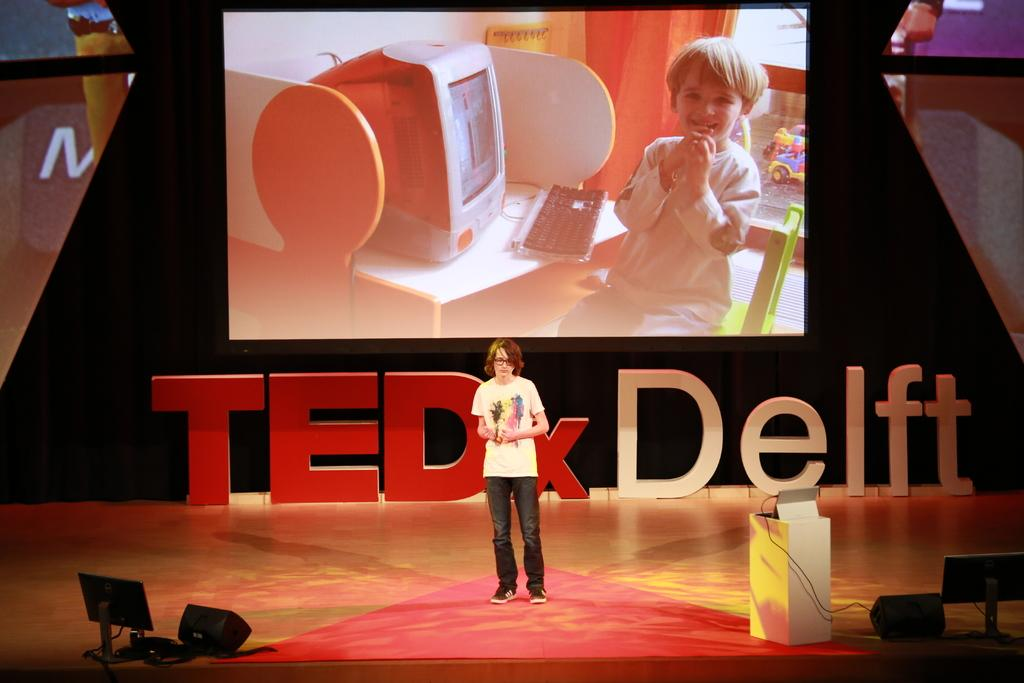Who or what is present in the image? There is a person in the image. What can be seen on the stage? There is a podium and other objects on the stage. What color are some of the objects in the image? There are black color objects in the image. What is visible in the background of the image? There are screens, letter boards, and a black curtain in the background of the image. Can you tell me how many grapes are on the writer's desk in the image? There is no writer or desk present in the image, and therefore no grapes can be observed. 